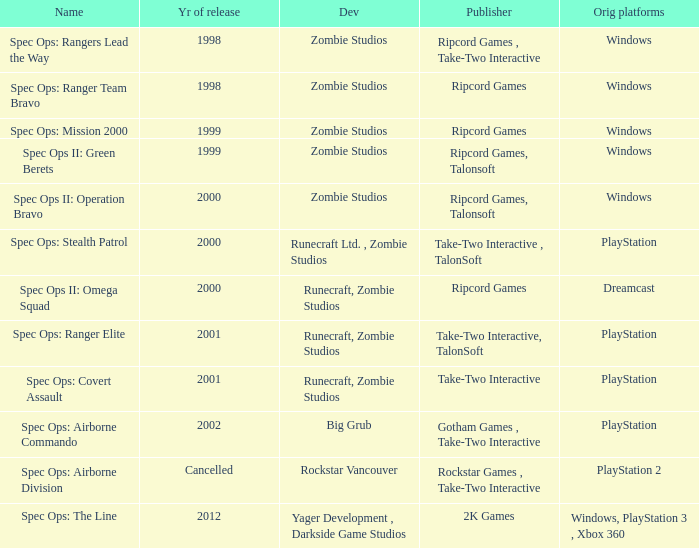Which developer has a year of cancelled releases? Rockstar Vancouver. 